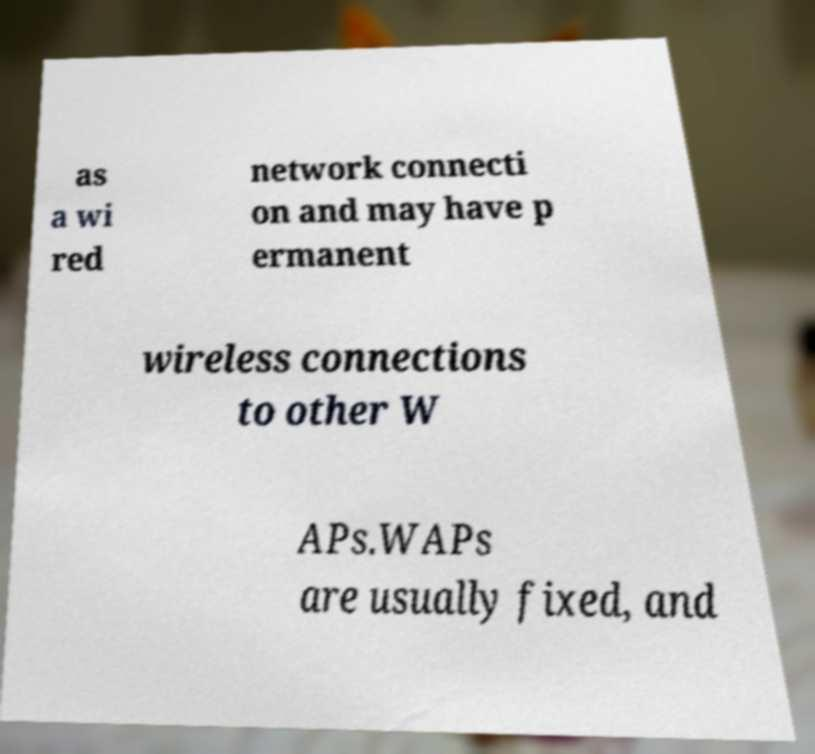I need the written content from this picture converted into text. Can you do that? as a wi red network connecti on and may have p ermanent wireless connections to other W APs.WAPs are usually fixed, and 